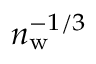Convert formula to latex. <formula><loc_0><loc_0><loc_500><loc_500>n _ { w } ^ { - 1 / 3 }</formula> 